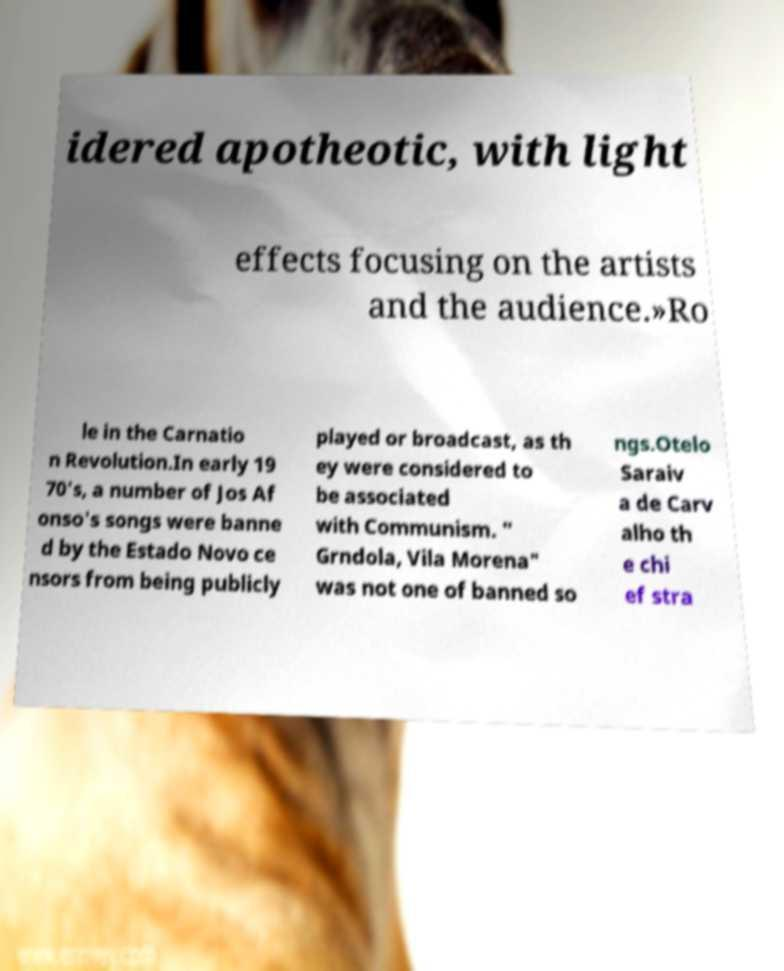I need the written content from this picture converted into text. Can you do that? idered apotheotic, with light effects focusing on the artists and the audience.»Ro le in the Carnatio n Revolution.In early 19 70's, a number of Jos Af onso's songs were banne d by the Estado Novo ce nsors from being publicly played or broadcast, as th ey were considered to be associated with Communism. " Grndola, Vila Morena" was not one of banned so ngs.Otelo Saraiv a de Carv alho th e chi ef stra 